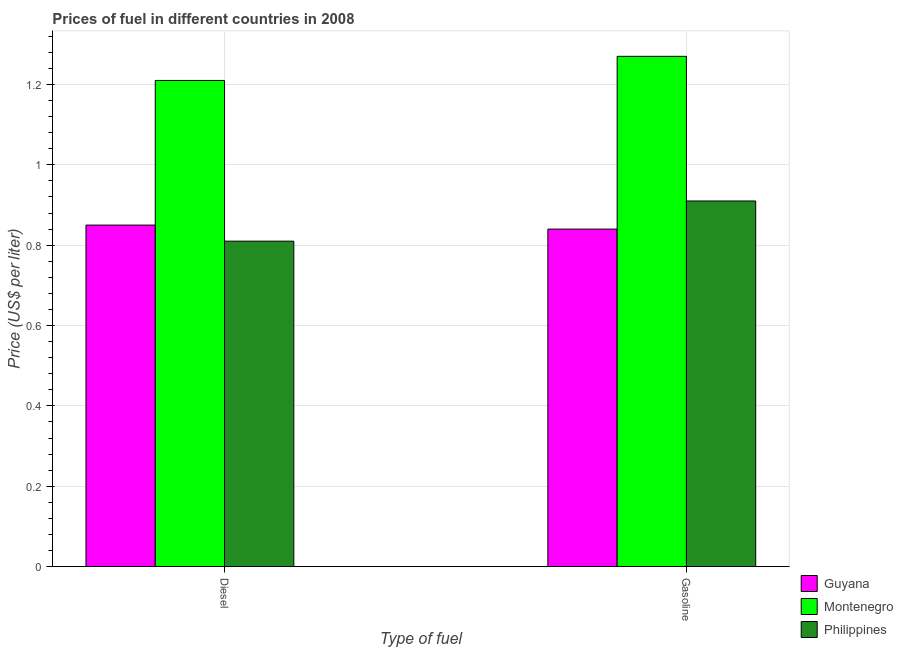How many groups of bars are there?
Ensure brevity in your answer.  2. Are the number of bars per tick equal to the number of legend labels?
Keep it short and to the point. Yes. Are the number of bars on each tick of the X-axis equal?
Your response must be concise. Yes. What is the label of the 1st group of bars from the left?
Your answer should be compact. Diesel. What is the diesel price in Montenegro?
Make the answer very short. 1.21. Across all countries, what is the maximum diesel price?
Your answer should be compact. 1.21. Across all countries, what is the minimum gasoline price?
Your response must be concise. 0.84. In which country was the gasoline price maximum?
Your answer should be very brief. Montenegro. In which country was the gasoline price minimum?
Provide a succinct answer. Guyana. What is the total diesel price in the graph?
Your response must be concise. 2.87. What is the difference between the gasoline price in Montenegro and that in Philippines?
Keep it short and to the point. 0.36. What is the difference between the gasoline price in Montenegro and the diesel price in Guyana?
Offer a terse response. 0.42. What is the average diesel price per country?
Keep it short and to the point. 0.96. What is the difference between the gasoline price and diesel price in Philippines?
Provide a succinct answer. 0.1. In how many countries, is the gasoline price greater than 1.12 US$ per litre?
Keep it short and to the point. 1. What is the ratio of the gasoline price in Montenegro to that in Guyana?
Offer a terse response. 1.51. Is the diesel price in Philippines less than that in Guyana?
Provide a succinct answer. Yes. In how many countries, is the diesel price greater than the average diesel price taken over all countries?
Offer a terse response. 1. What does the 2nd bar from the left in Gasoline represents?
Offer a terse response. Montenegro. What does the 2nd bar from the right in Diesel represents?
Your answer should be very brief. Montenegro. Are all the bars in the graph horizontal?
Offer a very short reply. No. What is the difference between two consecutive major ticks on the Y-axis?
Your answer should be very brief. 0.2. Are the values on the major ticks of Y-axis written in scientific E-notation?
Give a very brief answer. No. How many legend labels are there?
Give a very brief answer. 3. How are the legend labels stacked?
Offer a terse response. Vertical. What is the title of the graph?
Your response must be concise. Prices of fuel in different countries in 2008. Does "Swaziland" appear as one of the legend labels in the graph?
Keep it short and to the point. No. What is the label or title of the X-axis?
Provide a succinct answer. Type of fuel. What is the label or title of the Y-axis?
Your response must be concise. Price (US$ per liter). What is the Price (US$ per liter) in Montenegro in Diesel?
Offer a very short reply. 1.21. What is the Price (US$ per liter) in Philippines in Diesel?
Make the answer very short. 0.81. What is the Price (US$ per liter) of Guyana in Gasoline?
Make the answer very short. 0.84. What is the Price (US$ per liter) in Montenegro in Gasoline?
Make the answer very short. 1.27. What is the Price (US$ per liter) in Philippines in Gasoline?
Ensure brevity in your answer.  0.91. Across all Type of fuel, what is the maximum Price (US$ per liter) of Montenegro?
Your response must be concise. 1.27. Across all Type of fuel, what is the maximum Price (US$ per liter) of Philippines?
Ensure brevity in your answer.  0.91. Across all Type of fuel, what is the minimum Price (US$ per liter) in Guyana?
Provide a short and direct response. 0.84. Across all Type of fuel, what is the minimum Price (US$ per liter) of Montenegro?
Ensure brevity in your answer.  1.21. Across all Type of fuel, what is the minimum Price (US$ per liter) in Philippines?
Offer a terse response. 0.81. What is the total Price (US$ per liter) of Guyana in the graph?
Your response must be concise. 1.69. What is the total Price (US$ per liter) of Montenegro in the graph?
Your answer should be very brief. 2.48. What is the total Price (US$ per liter) in Philippines in the graph?
Keep it short and to the point. 1.72. What is the difference between the Price (US$ per liter) in Montenegro in Diesel and that in Gasoline?
Keep it short and to the point. -0.06. What is the difference between the Price (US$ per liter) of Guyana in Diesel and the Price (US$ per liter) of Montenegro in Gasoline?
Your answer should be compact. -0.42. What is the difference between the Price (US$ per liter) in Guyana in Diesel and the Price (US$ per liter) in Philippines in Gasoline?
Your answer should be compact. -0.06. What is the difference between the Price (US$ per liter) in Montenegro in Diesel and the Price (US$ per liter) in Philippines in Gasoline?
Provide a succinct answer. 0.3. What is the average Price (US$ per liter) of Guyana per Type of fuel?
Your response must be concise. 0.84. What is the average Price (US$ per liter) in Montenegro per Type of fuel?
Your answer should be very brief. 1.24. What is the average Price (US$ per liter) in Philippines per Type of fuel?
Make the answer very short. 0.86. What is the difference between the Price (US$ per liter) of Guyana and Price (US$ per liter) of Montenegro in Diesel?
Your answer should be compact. -0.36. What is the difference between the Price (US$ per liter) of Montenegro and Price (US$ per liter) of Philippines in Diesel?
Ensure brevity in your answer.  0.4. What is the difference between the Price (US$ per liter) in Guyana and Price (US$ per liter) in Montenegro in Gasoline?
Your response must be concise. -0.43. What is the difference between the Price (US$ per liter) of Guyana and Price (US$ per liter) of Philippines in Gasoline?
Your answer should be very brief. -0.07. What is the difference between the Price (US$ per liter) in Montenegro and Price (US$ per liter) in Philippines in Gasoline?
Ensure brevity in your answer.  0.36. What is the ratio of the Price (US$ per liter) of Guyana in Diesel to that in Gasoline?
Ensure brevity in your answer.  1.01. What is the ratio of the Price (US$ per liter) of Montenegro in Diesel to that in Gasoline?
Offer a terse response. 0.95. What is the ratio of the Price (US$ per liter) of Philippines in Diesel to that in Gasoline?
Make the answer very short. 0.89. What is the difference between the highest and the second highest Price (US$ per liter) of Philippines?
Your answer should be very brief. 0.1. 